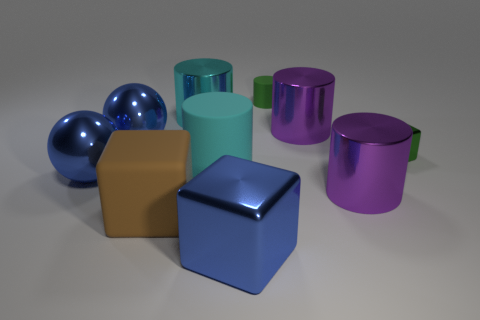Are there any large metal objects that are behind the large cyan thing in front of the big cyan metal cylinder?
Offer a terse response. Yes. There is a small cube; are there any cyan metal cylinders right of it?
Your answer should be compact. No. Do the big rubber thing that is behind the big brown block and the small green metallic thing have the same shape?
Offer a very short reply. No. How many other matte things have the same shape as the small rubber object?
Offer a very short reply. 1. Is there a large blue block that has the same material as the tiny block?
Offer a terse response. Yes. What is the big brown thing that is in front of the large cyan object in front of the small green cube made of?
Make the answer very short. Rubber. There is a green matte thing that is right of the large cyan metallic thing; how big is it?
Make the answer very short. Small. Does the tiny block have the same color as the large matte thing that is right of the brown rubber object?
Offer a terse response. No. Is there a ball of the same color as the small cylinder?
Offer a terse response. No. Is the brown thing made of the same material as the green thing in front of the tiny matte thing?
Give a very brief answer. No. 